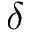Convert formula to latex. <formula><loc_0><loc_0><loc_500><loc_500>\delta</formula> 